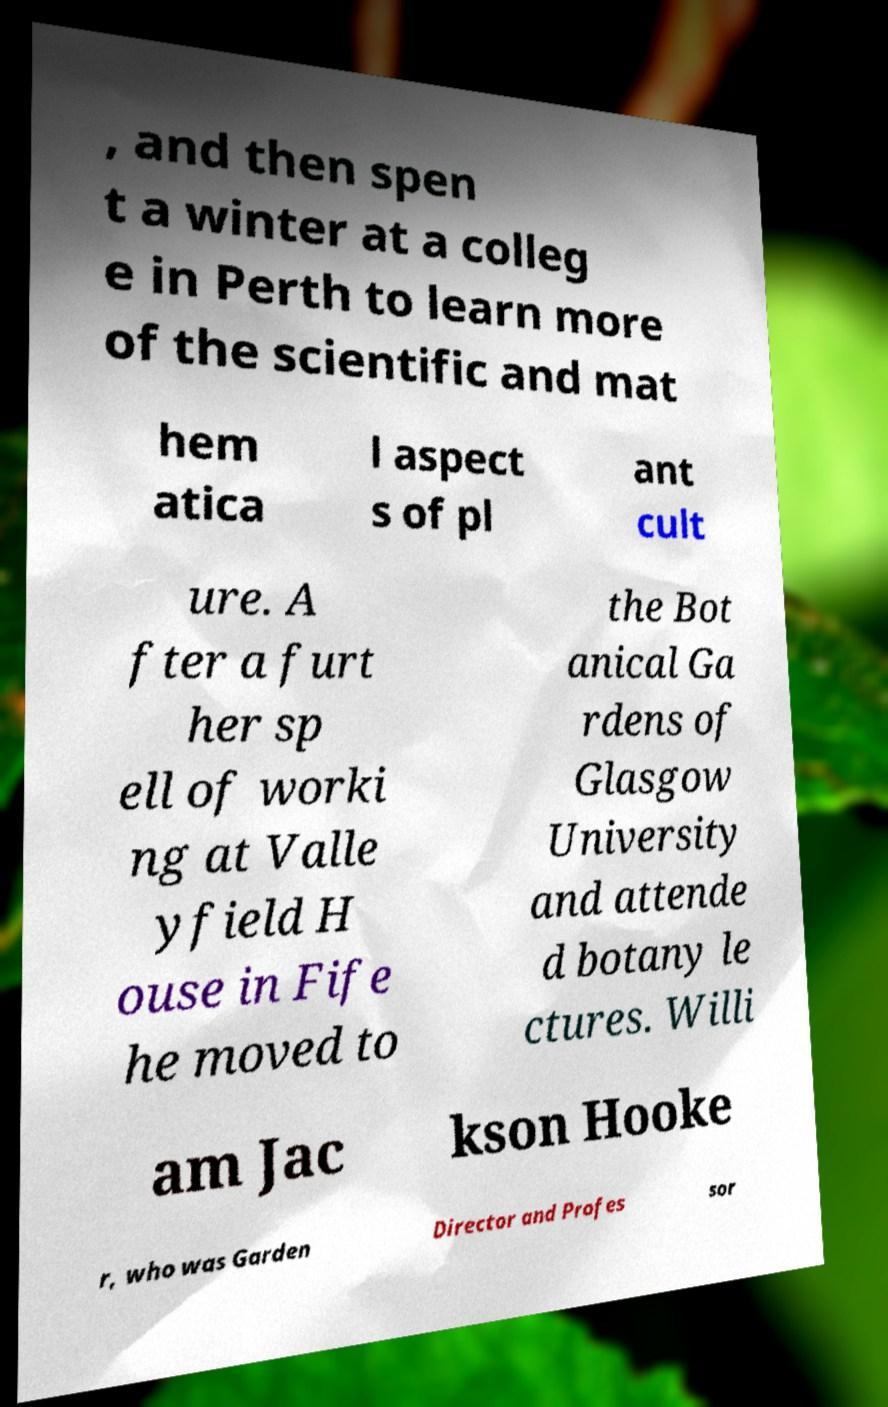Please identify and transcribe the text found in this image. , and then spen t a winter at a colleg e in Perth to learn more of the scientific and mat hem atica l aspect s of pl ant cult ure. A fter a furt her sp ell of worki ng at Valle yfield H ouse in Fife he moved to the Bot anical Ga rdens of Glasgow University and attende d botany le ctures. Willi am Jac kson Hooke r, who was Garden Director and Profes sor 